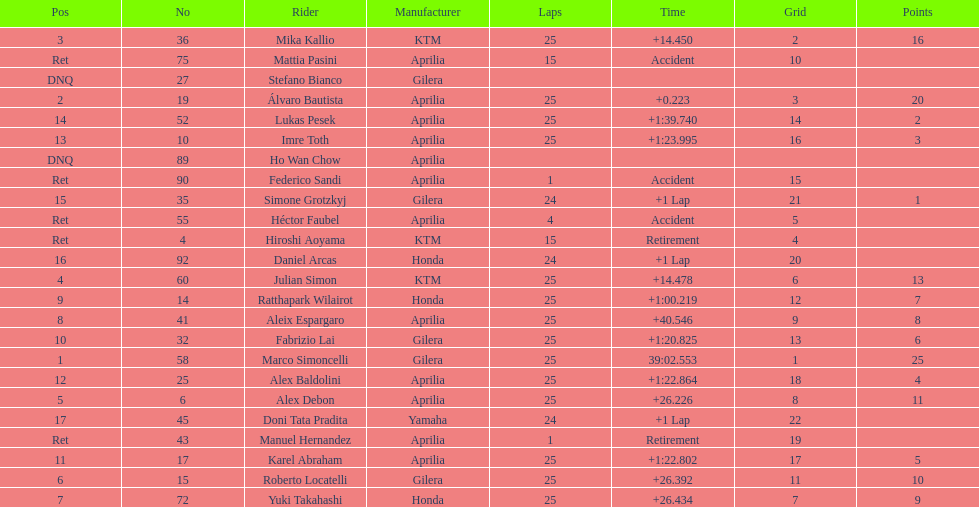What is the total number of laps performed by rider imre toth? 25. 